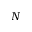<formula> <loc_0><loc_0><loc_500><loc_500>N</formula> 